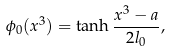<formula> <loc_0><loc_0><loc_500><loc_500>\phi _ { 0 } ( x ^ { 3 } ) = \tanh \frac { x ^ { 3 } - a } { 2 l _ { 0 } } ,</formula> 